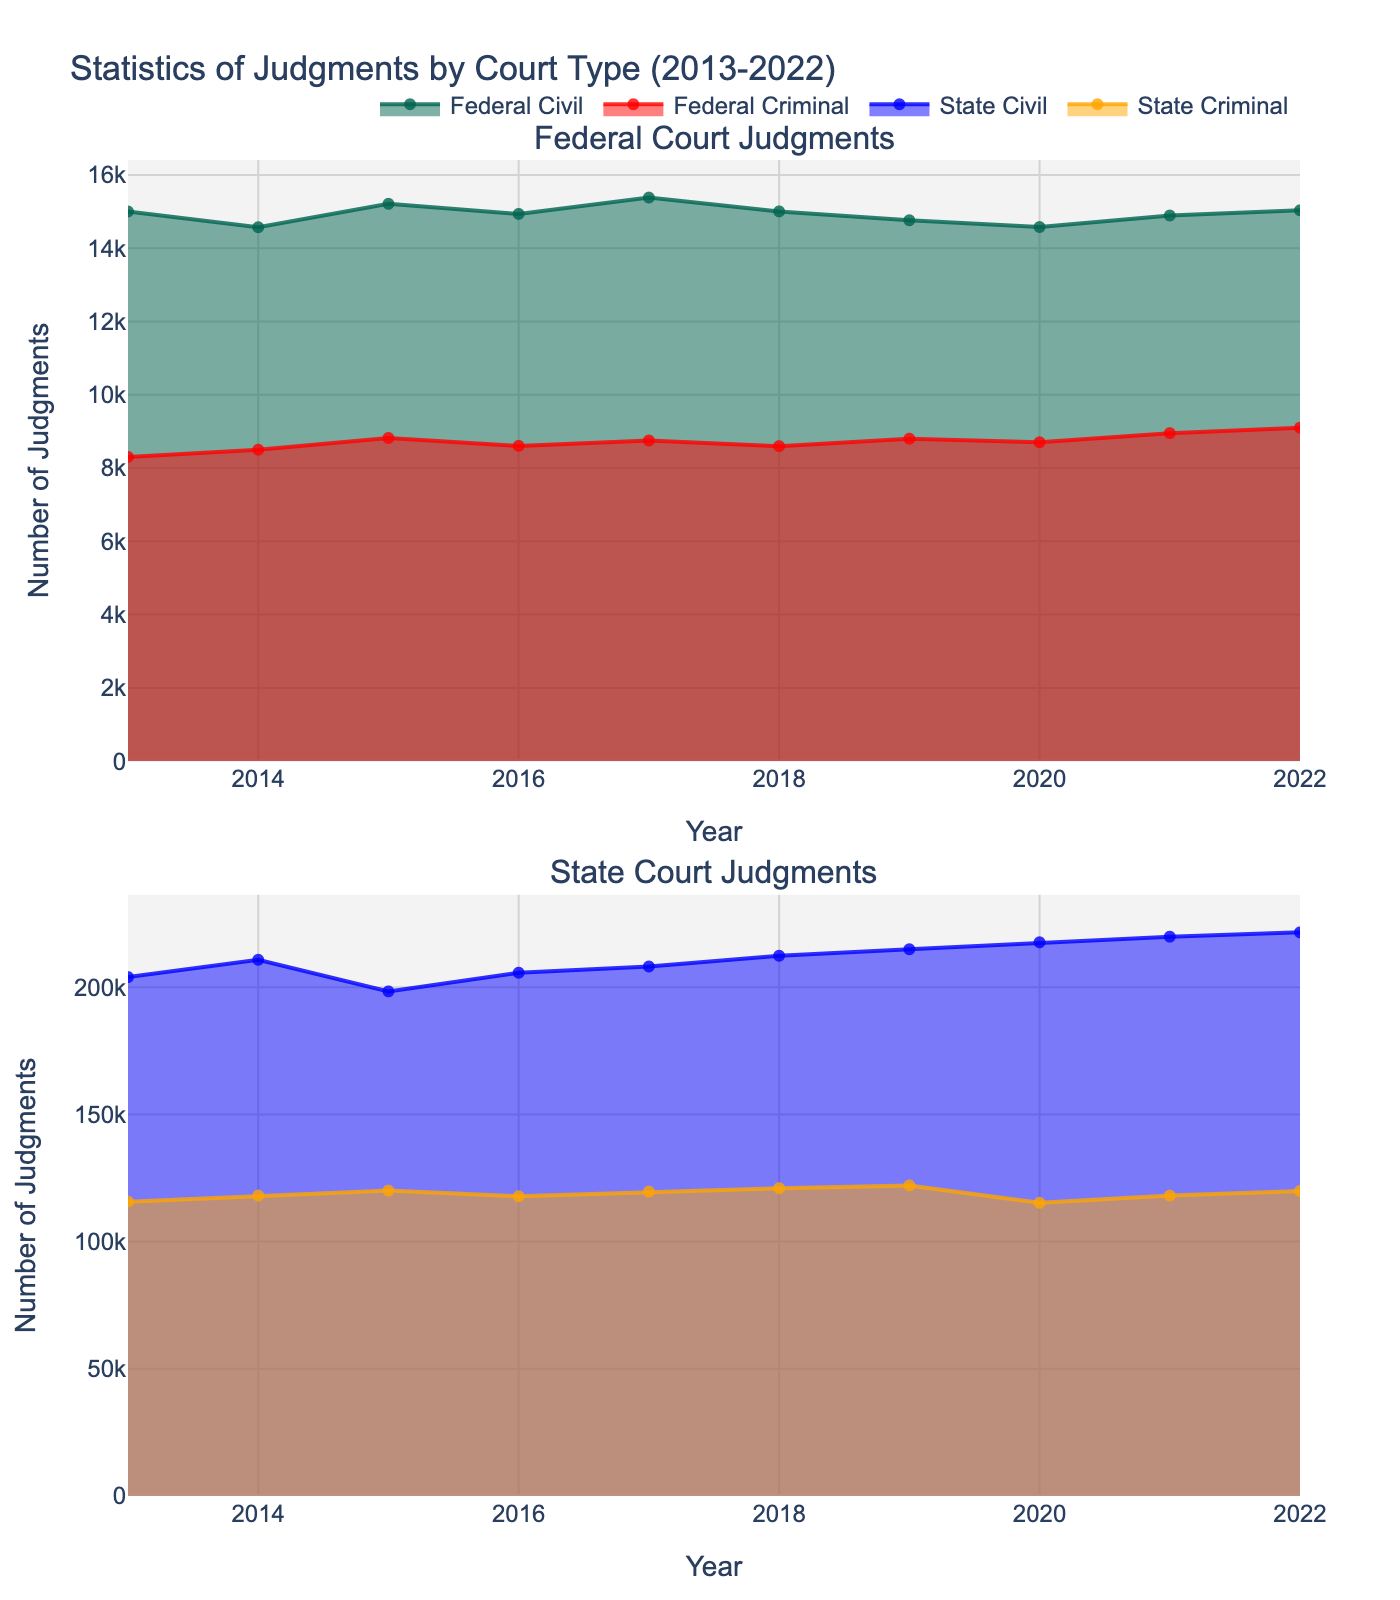What is the title of the figure? The title of the figure is shown at the top and it tells the topic of the figure.
Answer: Statistics of Judgments by Court Type (2013-2022) Which court type had the highest number of civil judgments in 2022? To determine this, compare the values for federal and state civil judgments in 2022 shown in the area chart.
Answer: State Civil What is the trend for federal criminal judgments from 2013 to 2022? Observe the line representing federal criminal judgments in the top subplot. Note if it is increasing, decreasing, or remaining steady.
Answer: Increasing How many data points are displayed in each subplot? Look at the x-axis which represents the years from 2013 to 2022. Each year represents one data point. Count the number of years.
Answer: 10 In which year did state civil judgments appear to peak? Identify the highest point in the area chart for state civil judgments in the bottom subplot and note the corresponding year on the x-axis.
Answer: 2022 What is the difference in the number of state criminal judgments between 2013 and 2022? Extract the values for state criminal judgments in 2013 and 2022 from the chart and subtract the earlier value from the later value.
Answer: 4188 Comparing 2020 to 2021, did federal civil judgments increase or decrease? Look at the plot for federal civil judgments and compare the heights of the area in 2020 and 2021.
Answer: Increase What is the average number of federal civil judgments over the decade? Sum all the values of federal civil judgments from 2013 to 2022 and divide by the number of years, which is 10.
Answer: 14937.2 Which court type had more criminal judgments overall: federal or state? Sum all annual values for federal criminal judgments and state criminal judgments across the years and compare the totals.
Answer: State How does the trend of federal civil judgments compare with state civil judgments from 2013 to 2022? Compare the shape and direction of the federal civil judgments line in the top subplot with the state civil judgments line in the bottom subplot over the decade.
Answer: State increases steadily while Federal fluctuates 